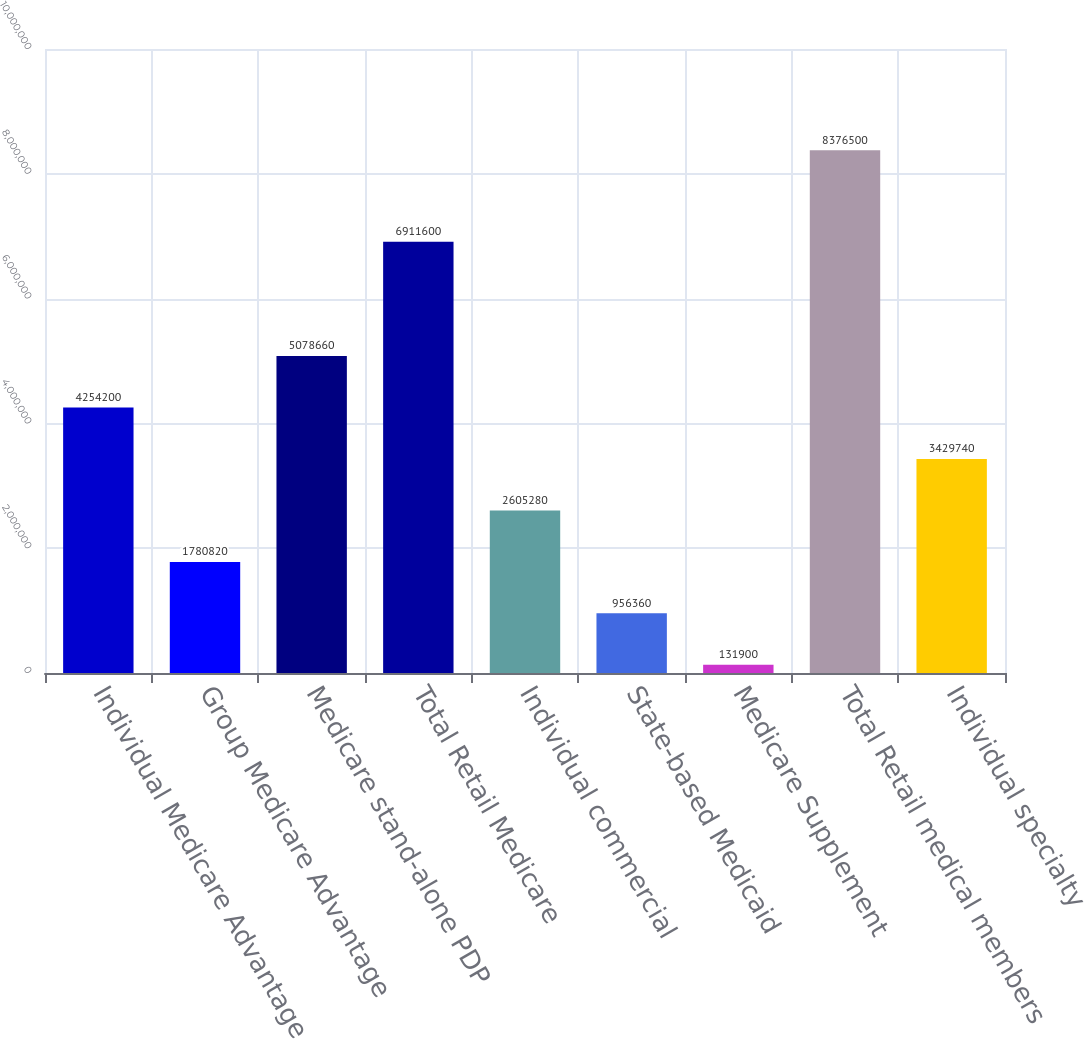Convert chart. <chart><loc_0><loc_0><loc_500><loc_500><bar_chart><fcel>Individual Medicare Advantage<fcel>Group Medicare Advantage<fcel>Medicare stand-alone PDP<fcel>Total Retail Medicare<fcel>Individual commercial<fcel>State-based Medicaid<fcel>Medicare Supplement<fcel>Total Retail medical members<fcel>Individual specialty<nl><fcel>4.2542e+06<fcel>1.78082e+06<fcel>5.07866e+06<fcel>6.9116e+06<fcel>2.60528e+06<fcel>956360<fcel>131900<fcel>8.3765e+06<fcel>3.42974e+06<nl></chart> 